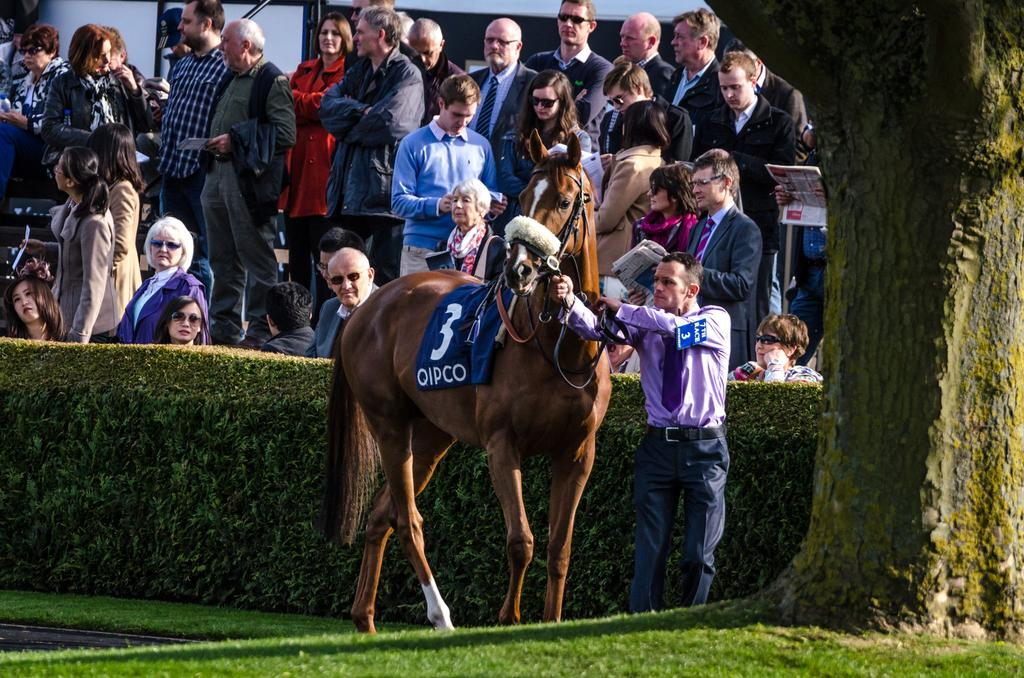What can be seen in the image involving people? There are people standing in the image. Can you describe the interaction between a man and an animal in the image? A man is standing with a horse in the image. What type of vegetation is present in the image? There is a plant and a tree in the image. How does the sink contribute to the image? There is no sink present in the image. 